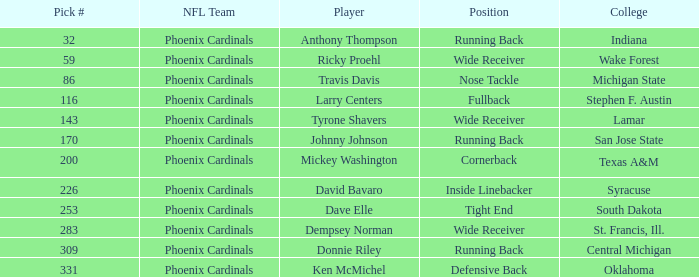Which player was a running back from San Jose State? Johnny Johnson. 